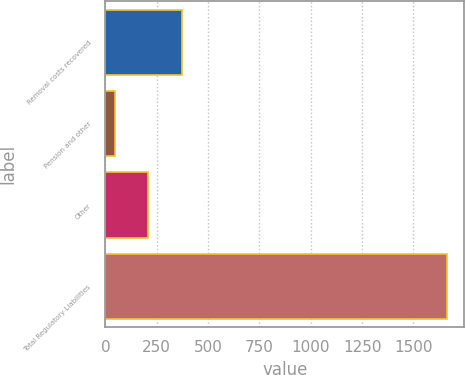<chart> <loc_0><loc_0><loc_500><loc_500><bar_chart><fcel>Removal costs recovered<fcel>Pension and other<fcel>Other<fcel>Total Regulatory Liabilities<nl><fcel>371.2<fcel>48<fcel>209.6<fcel>1664<nl></chart> 